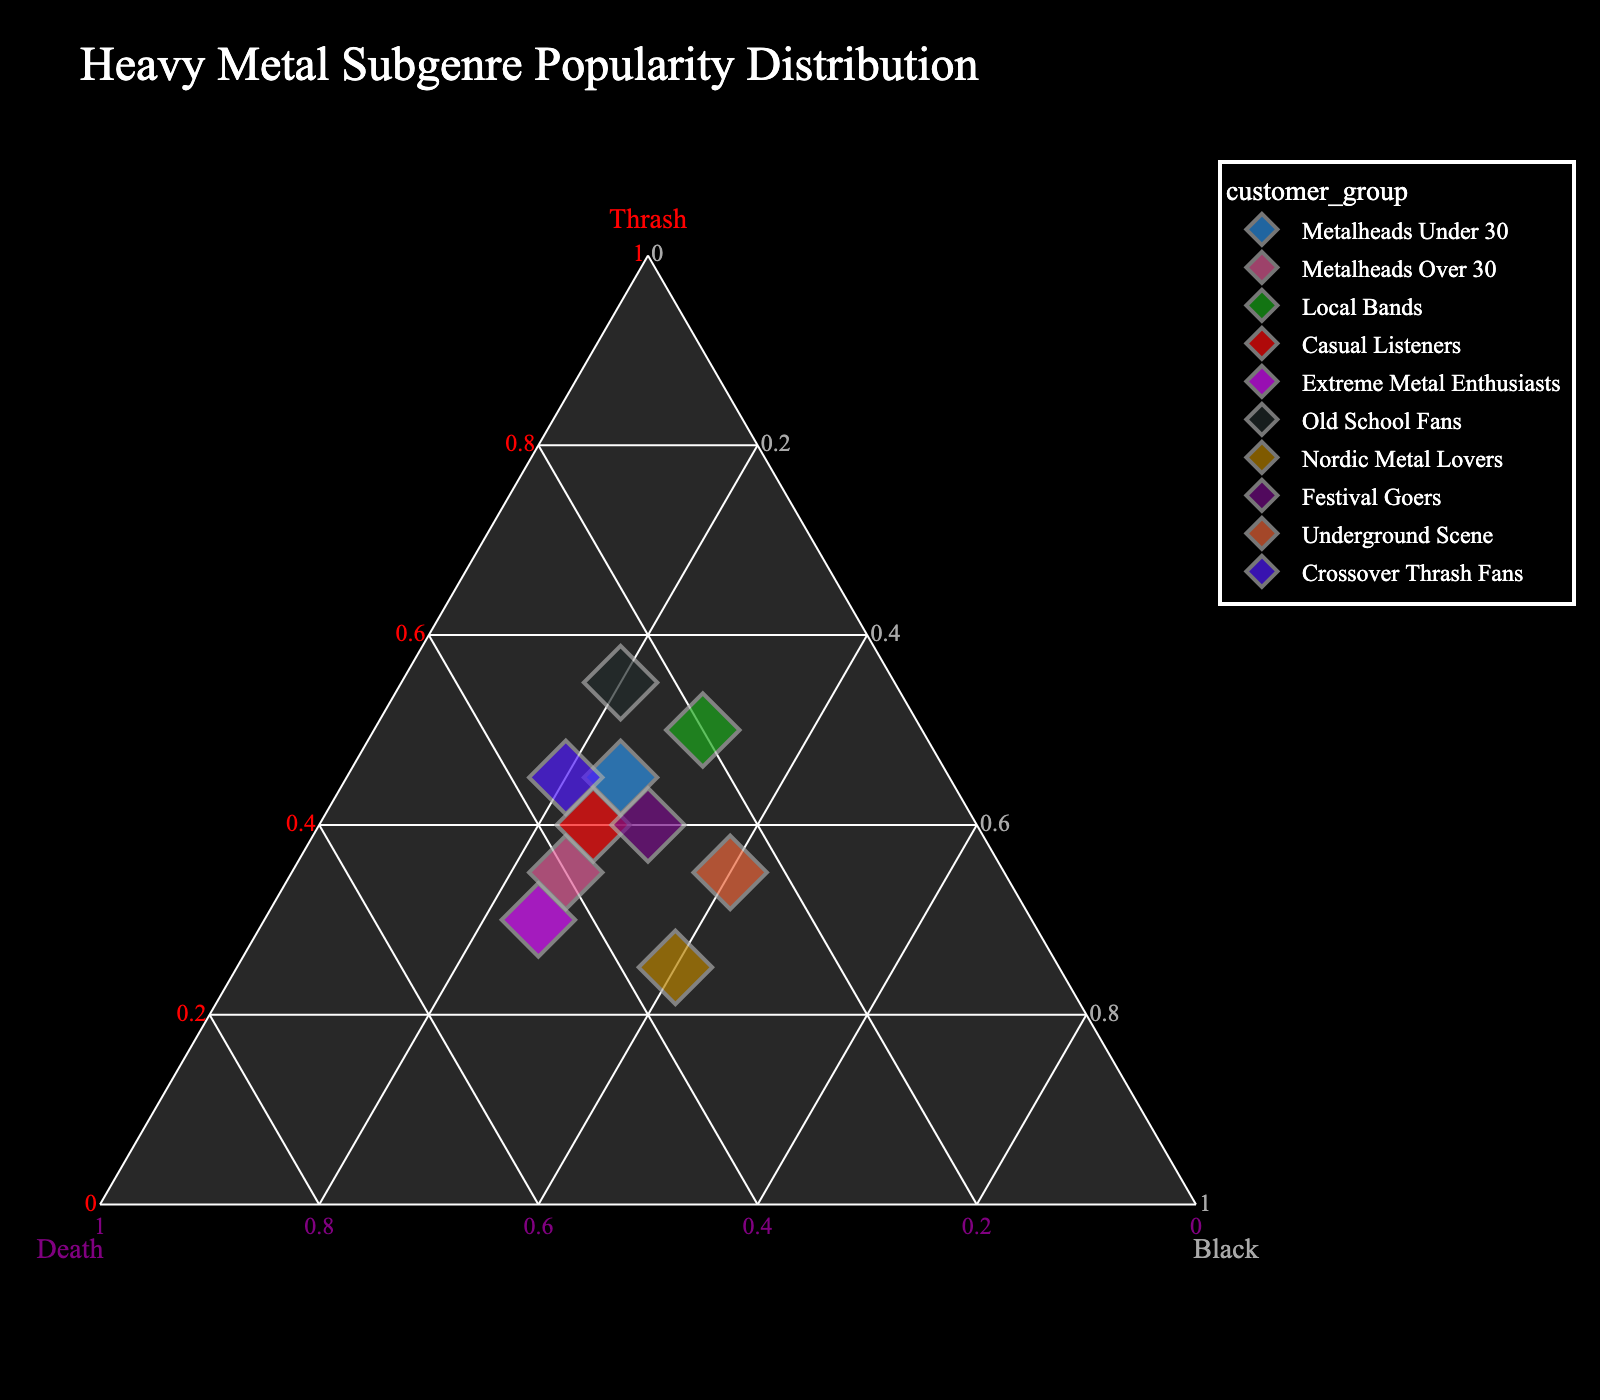What is the title of the plot? The title is displayed at the top of the plot in large font. It provides an overall description of what the plot represents.
Answer: Heavy Metal Subgenre Popularity Distribution Which subgenre is most popular among Old School Fans? In a ternary plot, you look at the point labeled "Old School Fans" and check its position relative to the three axes representing thrash, death, and black metal.
Answer: Thrash Which customer group has an equal popularity distribution for black and thrash metal? On a ternary plot, this would correspond to a point lying on the line where the percentages of black and thrash metal are the same.
Answer: Festival Goers What's the average popularity percentage of death metal for Festival Goers and Death Metal Enthusiasts? Find the death metal percentages for both groups from the plot, which are 30% and 45% respectively, then calculate the average: (30 + 45) / 2 = 37.5%.
Answer: 37.5% Which customer group prefers black metal the most? Identify the point that is closest to the black metal apex, indicating the highest percentage of black metal.
Answer: Nordic Metal Lovers Compare the preference for thrash metal between Casual Listeners and Crossover Thrash Fans. Look at the positions of the points labeled "Casual Listeners" and "Crossover Thrash Fans" relative to the thrash axis. Casual Listeners are at 40% and Crossover Thrash Fans are at 45%.
Answer: Crossover Thrash Fans prefer thrash metal more What is the percentage difference in death metal preference between Metalheads Over 30 and Metalheads Under 30? Metalheads Over 30 prefer death metal at 40% and Metalheads Under 30 at 30%. The difference is 40% - 30% = 10%.
Answer: 10% Which customer group is closest to having a balanced popularity distribution across all three subgenres? The point closest to the center of the ternary plot represents a balanced distribution. In this case, you look for a point that is nearly equidistant from all three axes.
Answer: Festival Goers Identify the customer groups with a higher preference for death metal than black metal. Locate the points that are closer to the death metal axis compared to the black metal axis. These are "Metalheads Over 30", "Casual Listeners", "Extreme Metal Enthusiasts", and "Old School Fans".
Answer: Metalheads Over 30, Casual Listeners, Extreme Metal Enthusiasts, Old School Fans 